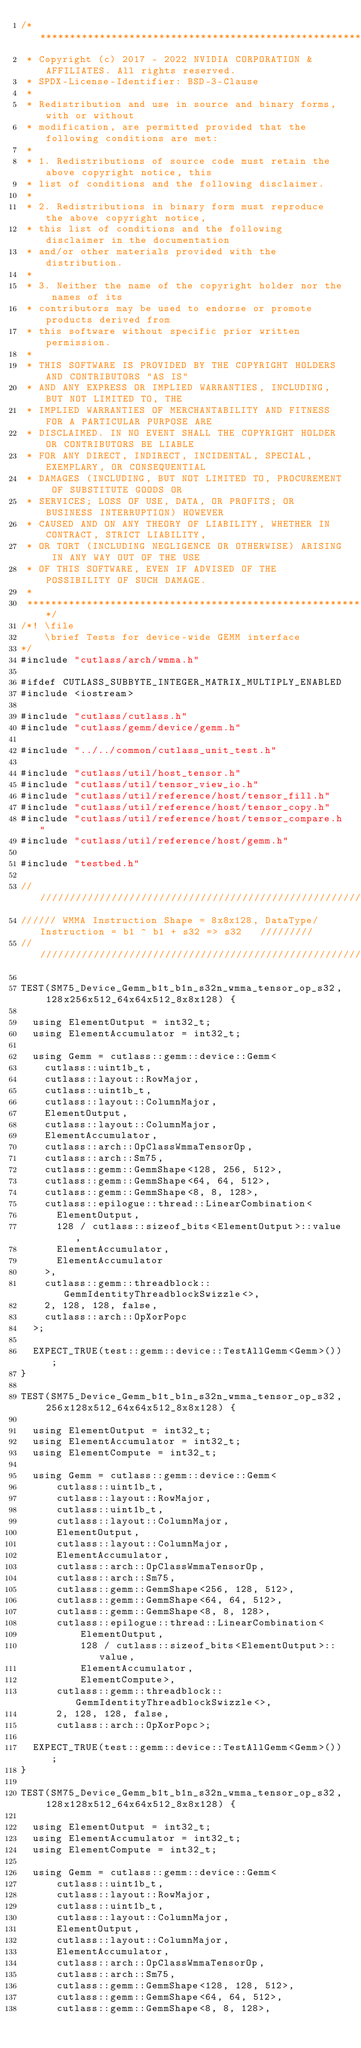<code> <loc_0><loc_0><loc_500><loc_500><_Cuda_>/***************************************************************************************************
 * Copyright (c) 2017 - 2022 NVIDIA CORPORATION & AFFILIATES. All rights reserved.
 * SPDX-License-Identifier: BSD-3-Clause
 *
 * Redistribution and use in source and binary forms, with or without
 * modification, are permitted provided that the following conditions are met:
 *
 * 1. Redistributions of source code must retain the above copyright notice, this
 * list of conditions and the following disclaimer.
 *
 * 2. Redistributions in binary form must reproduce the above copyright notice,
 * this list of conditions and the following disclaimer in the documentation
 * and/or other materials provided with the distribution.
 *
 * 3. Neither the name of the copyright holder nor the names of its
 * contributors may be used to endorse or promote products derived from
 * this software without specific prior written permission.
 *
 * THIS SOFTWARE IS PROVIDED BY THE COPYRIGHT HOLDERS AND CONTRIBUTORS "AS IS"
 * AND ANY EXPRESS OR IMPLIED WARRANTIES, INCLUDING, BUT NOT LIMITED TO, THE
 * IMPLIED WARRANTIES OF MERCHANTABILITY AND FITNESS FOR A PARTICULAR PURPOSE ARE
 * DISCLAIMED. IN NO EVENT SHALL THE COPYRIGHT HOLDER OR CONTRIBUTORS BE LIABLE
 * FOR ANY DIRECT, INDIRECT, INCIDENTAL, SPECIAL, EXEMPLARY, OR CONSEQUENTIAL
 * DAMAGES (INCLUDING, BUT NOT LIMITED TO, PROCUREMENT OF SUBSTITUTE GOODS OR
 * SERVICES; LOSS OF USE, DATA, OR PROFITS; OR BUSINESS INTERRUPTION) HOWEVER
 * CAUSED AND ON ANY THEORY OF LIABILITY, WHETHER IN CONTRACT, STRICT LIABILITY,
 * OR TORT (INCLUDING NEGLIGENCE OR OTHERWISE) ARISING IN ANY WAY OUT OF THE USE
 * OF THIS SOFTWARE, EVEN IF ADVISED OF THE POSSIBILITY OF SUCH DAMAGE.
 *
 **************************************************************************************************/
/*! \file
    \brief Tests for device-wide GEMM interface
*/
#include "cutlass/arch/wmma.h"

#ifdef CUTLASS_SUBBYTE_INTEGER_MATRIX_MULTIPLY_ENABLED
#include <iostream>

#include "cutlass/cutlass.h"
#include "cutlass/gemm/device/gemm.h"

#include "../../common/cutlass_unit_test.h"

#include "cutlass/util/host_tensor.h"
#include "cutlass/util/tensor_view_io.h"
#include "cutlass/util/reference/host/tensor_fill.h"
#include "cutlass/util/reference/host/tensor_copy.h"
#include "cutlass/util/reference/host/tensor_compare.h"
#include "cutlass/util/reference/host/gemm.h"

#include "testbed.h"

/////////////////////////////////////////////////////////////////////////////////////////////////
////// WMMA Instruction Shape = 8x8x128, DataType/Instruction = b1 ^ b1 + s32 => s32   /////////
/////////////////////////////////////////////////////////////////////////////////////////////////    

TEST(SM75_Device_Gemm_b1t_b1n_s32n_wmma_tensor_op_s32, 128x256x512_64x64x512_8x8x128) {

  using ElementOutput = int32_t;
  using ElementAccumulator = int32_t;

  using Gemm = cutlass::gemm::device::Gemm<
    cutlass::uint1b_t,
    cutlass::layout::RowMajor,
    cutlass::uint1b_t,
    cutlass::layout::ColumnMajor,
    ElementOutput,
    cutlass::layout::ColumnMajor,
    ElementAccumulator,
    cutlass::arch::OpClassWmmaTensorOp,
    cutlass::arch::Sm75,
    cutlass::gemm::GemmShape<128, 256, 512>,
    cutlass::gemm::GemmShape<64, 64, 512>,
    cutlass::gemm::GemmShape<8, 8, 128>,
    cutlass::epilogue::thread::LinearCombination<
      ElementOutput,
      128 / cutlass::sizeof_bits<ElementOutput>::value,
      ElementAccumulator,
      ElementAccumulator
    >,
    cutlass::gemm::threadblock::GemmIdentityThreadblockSwizzle<>,
    2, 128, 128, false, 
    cutlass::arch::OpXorPopc
  >;

  EXPECT_TRUE(test::gemm::device::TestAllGemm<Gemm>());
}

TEST(SM75_Device_Gemm_b1t_b1n_s32n_wmma_tensor_op_s32, 256x128x512_64x64x512_8x8x128) {

  using ElementOutput = int32_t;
  using ElementAccumulator = int32_t;
  using ElementCompute = int32_t;

  using Gemm = cutlass::gemm::device::Gemm<
      cutlass::uint1b_t, 
      cutlass::layout::RowMajor, 
      cutlass::uint1b_t,
      cutlass::layout::ColumnMajor, 
      ElementOutput, 
      cutlass::layout::ColumnMajor,
      ElementAccumulator, 
      cutlass::arch::OpClassWmmaTensorOp, 
      cutlass::arch::Sm75,
      cutlass::gemm::GemmShape<256, 128, 512>,
      cutlass::gemm::GemmShape<64, 64, 512>,
      cutlass::gemm::GemmShape<8, 8, 128>,
      cutlass::epilogue::thread::LinearCombination<
          ElementOutput, 
          128 / cutlass::sizeof_bits<ElementOutput>::value,
          ElementAccumulator, 
          ElementCompute>,
      cutlass::gemm::threadblock::GemmIdentityThreadblockSwizzle<>, 
      2, 128, 128, false, 
      cutlass::arch::OpXorPopc>;

  EXPECT_TRUE(test::gemm::device::TestAllGemm<Gemm>());
}

TEST(SM75_Device_Gemm_b1t_b1n_s32n_wmma_tensor_op_s32, 128x128x512_64x64x512_8x8x128) {

  using ElementOutput = int32_t;
  using ElementAccumulator = int32_t;
  using ElementCompute = int32_t;

  using Gemm = cutlass::gemm::device::Gemm<
      cutlass::uint1b_t, 
      cutlass::layout::RowMajor, 
      cutlass::uint1b_t,
      cutlass::layout::ColumnMajor, 
      ElementOutput, 
      cutlass::layout::ColumnMajor,
      ElementAccumulator, 
      cutlass::arch::OpClassWmmaTensorOp, 
      cutlass::arch::Sm75,
      cutlass::gemm::GemmShape<128, 128, 512>,
      cutlass::gemm::GemmShape<64, 64, 512>,
      cutlass::gemm::GemmShape<8, 8, 128>,</code> 